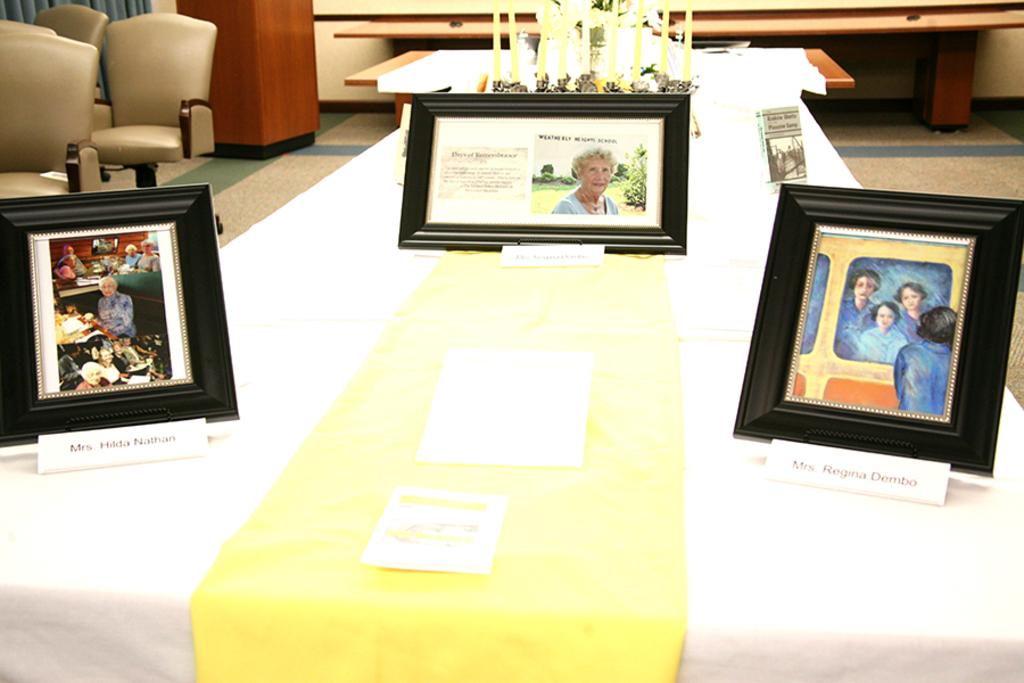What objects are present in the image that are used for displaying or hanging items? There are frames in the image that are used for displaying or hanging items. What objects are present in the image that provide light? There are candles in the image that provide light. What objects are present in the image that people can sit on? There are chairs in the image that people can sit on. What type of insect can be seen crawling on the table in the image? There is no table or insect present in the image. What type of meeting is taking place in the image? There is no meeting present in the image. 